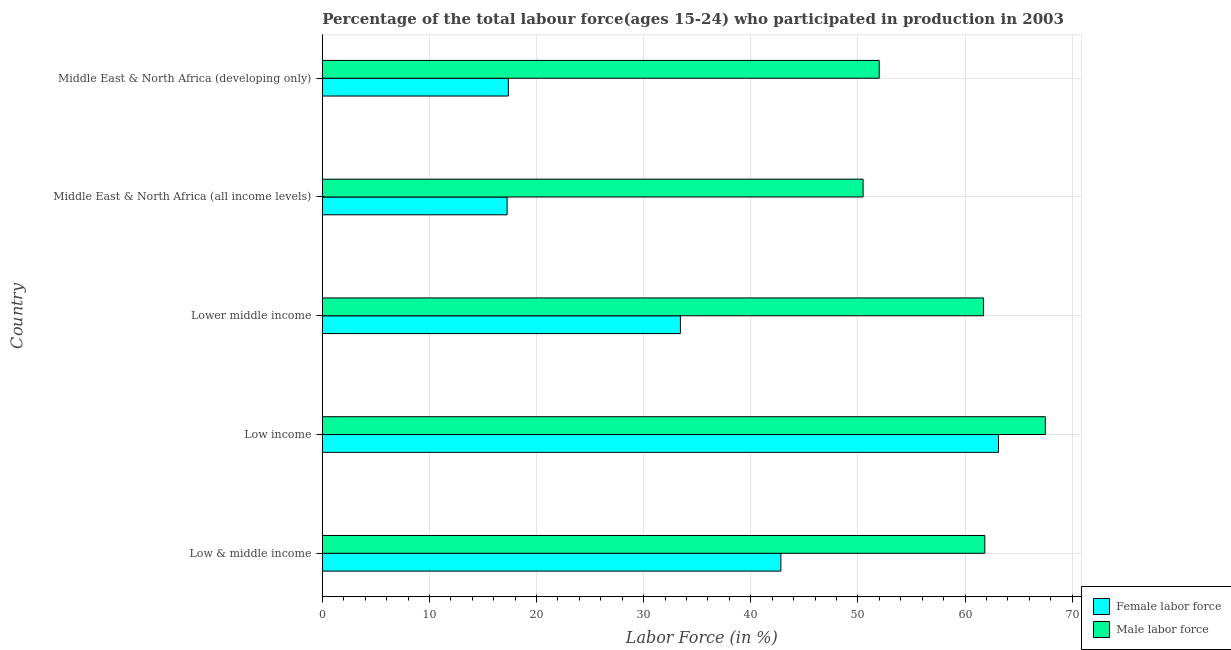How many groups of bars are there?
Offer a very short reply. 5. Are the number of bars per tick equal to the number of legend labels?
Ensure brevity in your answer.  Yes. Are the number of bars on each tick of the Y-axis equal?
Offer a terse response. Yes. What is the label of the 3rd group of bars from the top?
Offer a terse response. Lower middle income. What is the percentage of male labour force in Lower middle income?
Give a very brief answer. 61.73. Across all countries, what is the maximum percentage of male labour force?
Ensure brevity in your answer.  67.5. Across all countries, what is the minimum percentage of female labor force?
Give a very brief answer. 17.25. In which country was the percentage of female labor force maximum?
Provide a short and direct response. Low income. In which country was the percentage of male labour force minimum?
Your answer should be compact. Middle East & North Africa (all income levels). What is the total percentage of male labour force in the graph?
Provide a short and direct response. 293.55. What is the difference between the percentage of female labor force in Low & middle income and that in Lower middle income?
Keep it short and to the point. 9.38. What is the difference between the percentage of male labour force in Low & middle income and the percentage of female labor force in Low income?
Give a very brief answer. -1.28. What is the average percentage of male labour force per country?
Make the answer very short. 58.71. What is the difference between the percentage of female labor force and percentage of male labour force in Lower middle income?
Give a very brief answer. -28.3. In how many countries, is the percentage of female labor force greater than 56 %?
Offer a very short reply. 1. What is the ratio of the percentage of female labor force in Low income to that in Lower middle income?
Your answer should be compact. 1.89. Is the percentage of female labor force in Low & middle income less than that in Middle East & North Africa (developing only)?
Give a very brief answer. No. Is the difference between the percentage of female labor force in Low income and Middle East & North Africa (all income levels) greater than the difference between the percentage of male labour force in Low income and Middle East & North Africa (all income levels)?
Provide a succinct answer. Yes. What is the difference between the highest and the second highest percentage of male labour force?
Offer a very short reply. 5.65. What is the difference between the highest and the lowest percentage of male labour force?
Make the answer very short. 17.01. In how many countries, is the percentage of male labour force greater than the average percentage of male labour force taken over all countries?
Offer a terse response. 3. Is the sum of the percentage of male labour force in Low income and Middle East & North Africa (developing only) greater than the maximum percentage of female labor force across all countries?
Make the answer very short. Yes. What does the 2nd bar from the top in Lower middle income represents?
Provide a short and direct response. Female labor force. What does the 1st bar from the bottom in Lower middle income represents?
Provide a short and direct response. Female labor force. How many bars are there?
Offer a very short reply. 10. How many countries are there in the graph?
Your response must be concise. 5. Does the graph contain grids?
Offer a terse response. Yes. How are the legend labels stacked?
Your answer should be compact. Vertical. What is the title of the graph?
Offer a terse response. Percentage of the total labour force(ages 15-24) who participated in production in 2003. What is the label or title of the X-axis?
Your answer should be compact. Labor Force (in %). What is the Labor Force (in %) of Female labor force in Low & middle income?
Ensure brevity in your answer.  42.81. What is the Labor Force (in %) in Male labor force in Low & middle income?
Offer a terse response. 61.85. What is the Labor Force (in %) in Female labor force in Low income?
Provide a short and direct response. 63.12. What is the Labor Force (in %) in Male labor force in Low income?
Keep it short and to the point. 67.5. What is the Labor Force (in %) in Female labor force in Lower middle income?
Offer a terse response. 33.43. What is the Labor Force (in %) of Male labor force in Lower middle income?
Your response must be concise. 61.73. What is the Labor Force (in %) in Female labor force in Middle East & North Africa (all income levels)?
Give a very brief answer. 17.25. What is the Labor Force (in %) of Male labor force in Middle East & North Africa (all income levels)?
Your response must be concise. 50.48. What is the Labor Force (in %) in Female labor force in Middle East & North Africa (developing only)?
Offer a terse response. 17.37. What is the Labor Force (in %) of Male labor force in Middle East & North Africa (developing only)?
Your answer should be very brief. 51.99. Across all countries, what is the maximum Labor Force (in %) in Female labor force?
Make the answer very short. 63.12. Across all countries, what is the maximum Labor Force (in %) of Male labor force?
Ensure brevity in your answer.  67.5. Across all countries, what is the minimum Labor Force (in %) of Female labor force?
Ensure brevity in your answer.  17.25. Across all countries, what is the minimum Labor Force (in %) in Male labor force?
Provide a short and direct response. 50.48. What is the total Labor Force (in %) in Female labor force in the graph?
Keep it short and to the point. 173.98. What is the total Labor Force (in %) of Male labor force in the graph?
Give a very brief answer. 293.55. What is the difference between the Labor Force (in %) of Female labor force in Low & middle income and that in Low income?
Your response must be concise. -20.32. What is the difference between the Labor Force (in %) in Male labor force in Low & middle income and that in Low income?
Give a very brief answer. -5.65. What is the difference between the Labor Force (in %) of Female labor force in Low & middle income and that in Lower middle income?
Your answer should be very brief. 9.38. What is the difference between the Labor Force (in %) in Male labor force in Low & middle income and that in Lower middle income?
Give a very brief answer. 0.12. What is the difference between the Labor Force (in %) in Female labor force in Low & middle income and that in Middle East & North Africa (all income levels)?
Your answer should be very brief. 25.56. What is the difference between the Labor Force (in %) of Male labor force in Low & middle income and that in Middle East & North Africa (all income levels)?
Ensure brevity in your answer.  11.37. What is the difference between the Labor Force (in %) in Female labor force in Low & middle income and that in Middle East & North Africa (developing only)?
Offer a very short reply. 25.44. What is the difference between the Labor Force (in %) of Male labor force in Low & middle income and that in Middle East & North Africa (developing only)?
Ensure brevity in your answer.  9.86. What is the difference between the Labor Force (in %) in Female labor force in Low income and that in Lower middle income?
Your answer should be very brief. 29.7. What is the difference between the Labor Force (in %) of Male labor force in Low income and that in Lower middle income?
Offer a terse response. 5.77. What is the difference between the Labor Force (in %) in Female labor force in Low income and that in Middle East & North Africa (all income levels)?
Offer a terse response. 45.88. What is the difference between the Labor Force (in %) in Male labor force in Low income and that in Middle East & North Africa (all income levels)?
Ensure brevity in your answer.  17.01. What is the difference between the Labor Force (in %) of Female labor force in Low income and that in Middle East & North Africa (developing only)?
Your answer should be compact. 45.76. What is the difference between the Labor Force (in %) in Male labor force in Low income and that in Middle East & North Africa (developing only)?
Make the answer very short. 15.51. What is the difference between the Labor Force (in %) in Female labor force in Lower middle income and that in Middle East & North Africa (all income levels)?
Your response must be concise. 16.18. What is the difference between the Labor Force (in %) of Male labor force in Lower middle income and that in Middle East & North Africa (all income levels)?
Provide a short and direct response. 11.25. What is the difference between the Labor Force (in %) in Female labor force in Lower middle income and that in Middle East & North Africa (developing only)?
Ensure brevity in your answer.  16.06. What is the difference between the Labor Force (in %) in Male labor force in Lower middle income and that in Middle East & North Africa (developing only)?
Provide a short and direct response. 9.74. What is the difference between the Labor Force (in %) in Female labor force in Middle East & North Africa (all income levels) and that in Middle East & North Africa (developing only)?
Provide a succinct answer. -0.12. What is the difference between the Labor Force (in %) in Male labor force in Middle East & North Africa (all income levels) and that in Middle East & North Africa (developing only)?
Provide a short and direct response. -1.51. What is the difference between the Labor Force (in %) of Female labor force in Low & middle income and the Labor Force (in %) of Male labor force in Low income?
Offer a terse response. -24.69. What is the difference between the Labor Force (in %) in Female labor force in Low & middle income and the Labor Force (in %) in Male labor force in Lower middle income?
Your answer should be very brief. -18.92. What is the difference between the Labor Force (in %) of Female labor force in Low & middle income and the Labor Force (in %) of Male labor force in Middle East & North Africa (all income levels)?
Keep it short and to the point. -7.67. What is the difference between the Labor Force (in %) in Female labor force in Low & middle income and the Labor Force (in %) in Male labor force in Middle East & North Africa (developing only)?
Make the answer very short. -9.18. What is the difference between the Labor Force (in %) of Female labor force in Low income and the Labor Force (in %) of Male labor force in Lower middle income?
Ensure brevity in your answer.  1.4. What is the difference between the Labor Force (in %) in Female labor force in Low income and the Labor Force (in %) in Male labor force in Middle East & North Africa (all income levels)?
Give a very brief answer. 12.64. What is the difference between the Labor Force (in %) in Female labor force in Low income and the Labor Force (in %) in Male labor force in Middle East & North Africa (developing only)?
Provide a short and direct response. 11.13. What is the difference between the Labor Force (in %) in Female labor force in Lower middle income and the Labor Force (in %) in Male labor force in Middle East & North Africa (all income levels)?
Your response must be concise. -17.05. What is the difference between the Labor Force (in %) in Female labor force in Lower middle income and the Labor Force (in %) in Male labor force in Middle East & North Africa (developing only)?
Provide a succinct answer. -18.56. What is the difference between the Labor Force (in %) in Female labor force in Middle East & North Africa (all income levels) and the Labor Force (in %) in Male labor force in Middle East & North Africa (developing only)?
Make the answer very short. -34.74. What is the average Labor Force (in %) of Female labor force per country?
Offer a terse response. 34.8. What is the average Labor Force (in %) of Male labor force per country?
Your answer should be very brief. 58.71. What is the difference between the Labor Force (in %) of Female labor force and Labor Force (in %) of Male labor force in Low & middle income?
Make the answer very short. -19.04. What is the difference between the Labor Force (in %) of Female labor force and Labor Force (in %) of Male labor force in Low income?
Your response must be concise. -4.37. What is the difference between the Labor Force (in %) in Female labor force and Labor Force (in %) in Male labor force in Lower middle income?
Make the answer very short. -28.3. What is the difference between the Labor Force (in %) in Female labor force and Labor Force (in %) in Male labor force in Middle East & North Africa (all income levels)?
Give a very brief answer. -33.23. What is the difference between the Labor Force (in %) of Female labor force and Labor Force (in %) of Male labor force in Middle East & North Africa (developing only)?
Give a very brief answer. -34.63. What is the ratio of the Labor Force (in %) in Female labor force in Low & middle income to that in Low income?
Provide a short and direct response. 0.68. What is the ratio of the Labor Force (in %) in Male labor force in Low & middle income to that in Low income?
Your answer should be very brief. 0.92. What is the ratio of the Labor Force (in %) of Female labor force in Low & middle income to that in Lower middle income?
Your answer should be compact. 1.28. What is the ratio of the Labor Force (in %) in Female labor force in Low & middle income to that in Middle East & North Africa (all income levels)?
Make the answer very short. 2.48. What is the ratio of the Labor Force (in %) in Male labor force in Low & middle income to that in Middle East & North Africa (all income levels)?
Offer a terse response. 1.23. What is the ratio of the Labor Force (in %) of Female labor force in Low & middle income to that in Middle East & North Africa (developing only)?
Keep it short and to the point. 2.47. What is the ratio of the Labor Force (in %) of Male labor force in Low & middle income to that in Middle East & North Africa (developing only)?
Offer a terse response. 1.19. What is the ratio of the Labor Force (in %) of Female labor force in Low income to that in Lower middle income?
Make the answer very short. 1.89. What is the ratio of the Labor Force (in %) of Male labor force in Low income to that in Lower middle income?
Give a very brief answer. 1.09. What is the ratio of the Labor Force (in %) in Female labor force in Low income to that in Middle East & North Africa (all income levels)?
Provide a short and direct response. 3.66. What is the ratio of the Labor Force (in %) in Male labor force in Low income to that in Middle East & North Africa (all income levels)?
Keep it short and to the point. 1.34. What is the ratio of the Labor Force (in %) in Female labor force in Low income to that in Middle East & North Africa (developing only)?
Provide a succinct answer. 3.64. What is the ratio of the Labor Force (in %) in Male labor force in Low income to that in Middle East & North Africa (developing only)?
Your response must be concise. 1.3. What is the ratio of the Labor Force (in %) of Female labor force in Lower middle income to that in Middle East & North Africa (all income levels)?
Keep it short and to the point. 1.94. What is the ratio of the Labor Force (in %) of Male labor force in Lower middle income to that in Middle East & North Africa (all income levels)?
Keep it short and to the point. 1.22. What is the ratio of the Labor Force (in %) in Female labor force in Lower middle income to that in Middle East & North Africa (developing only)?
Provide a short and direct response. 1.93. What is the ratio of the Labor Force (in %) of Male labor force in Lower middle income to that in Middle East & North Africa (developing only)?
Provide a succinct answer. 1.19. What is the ratio of the Labor Force (in %) in Male labor force in Middle East & North Africa (all income levels) to that in Middle East & North Africa (developing only)?
Keep it short and to the point. 0.97. What is the difference between the highest and the second highest Labor Force (in %) of Female labor force?
Your answer should be compact. 20.32. What is the difference between the highest and the second highest Labor Force (in %) of Male labor force?
Provide a succinct answer. 5.65. What is the difference between the highest and the lowest Labor Force (in %) in Female labor force?
Your answer should be compact. 45.88. What is the difference between the highest and the lowest Labor Force (in %) in Male labor force?
Ensure brevity in your answer.  17.01. 